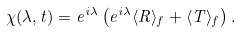Convert formula to latex. <formula><loc_0><loc_0><loc_500><loc_500>\chi ( \lambda , t ) = e ^ { i \lambda } \left ( e ^ { i \lambda } \langle R \rangle _ { f } + \langle T \rangle _ { f } \right ) .</formula> 